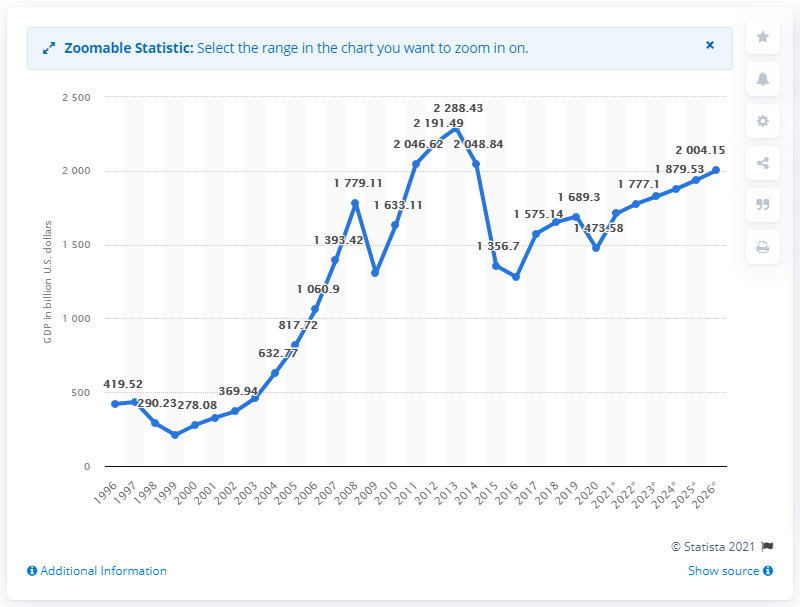Outline some significant characteristics in this image. The value of the variable fluctuates the most during the years 2014 and 2015. In 2020, the Gross Domestic Product (GDP) of Russia was 1473.58 billion dollars. In 2013, the Gross Domestic Product (GDP) reached its highest value. 